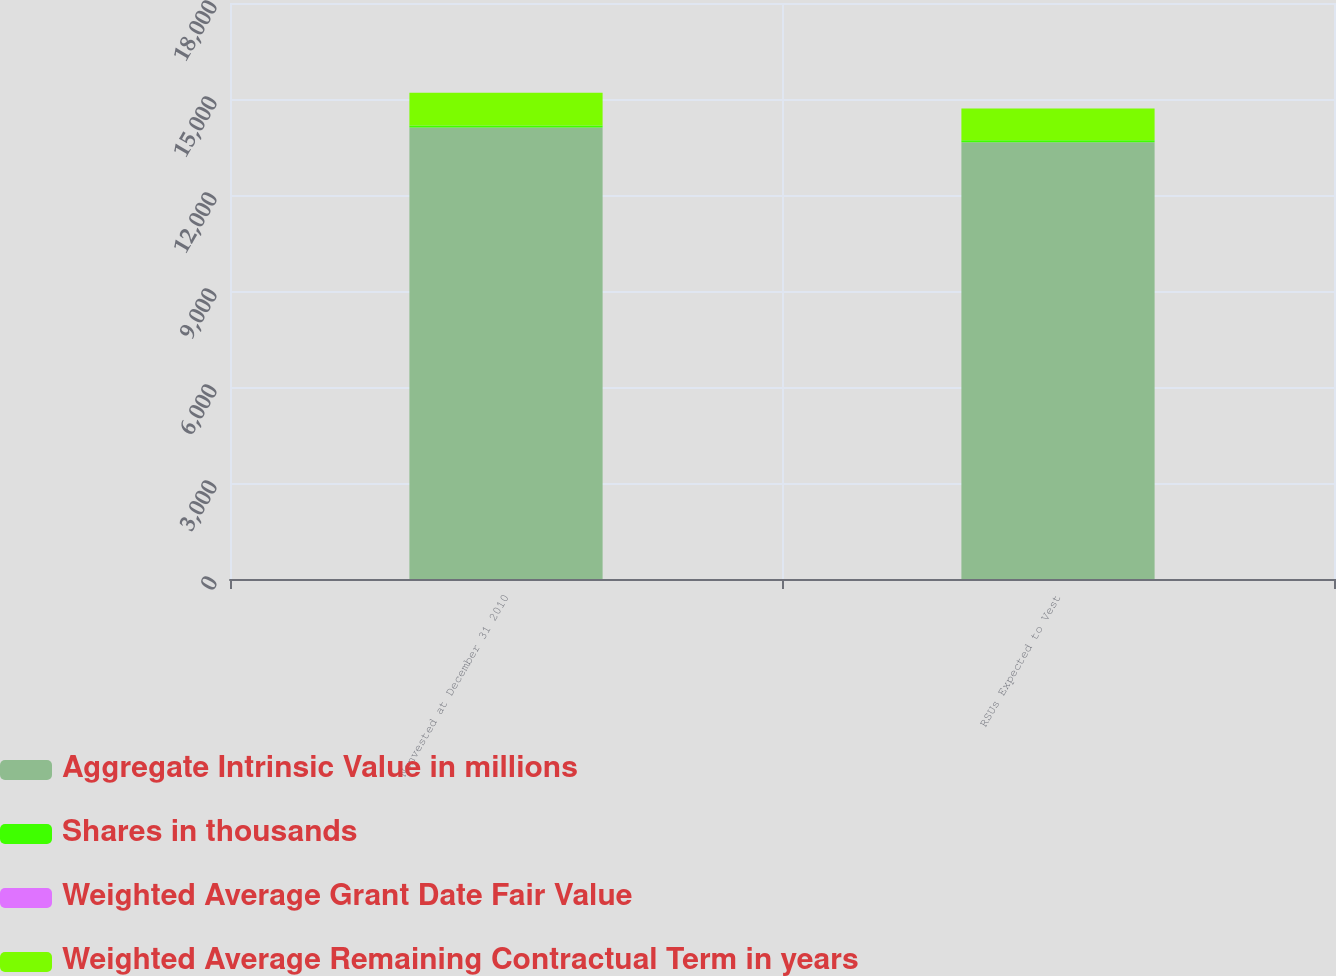<chart> <loc_0><loc_0><loc_500><loc_500><stacked_bar_chart><ecel><fcel>Nonvested at December 31 2010<fcel>RSUs Expected to Vest<nl><fcel>Aggregate Intrinsic Value in millions<fcel>14111<fcel>13649<nl><fcel>Shares in thousands<fcel>60.51<fcel>60.49<nl><fcel>Weighted Average Grant Date Fair Value<fcel>2.06<fcel>2.01<nl><fcel>Weighted Average Remaining Contractual Term in years<fcel>1024<fcel>991<nl></chart> 